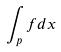<formula> <loc_0><loc_0><loc_500><loc_500>\int _ { p } f d x</formula> 